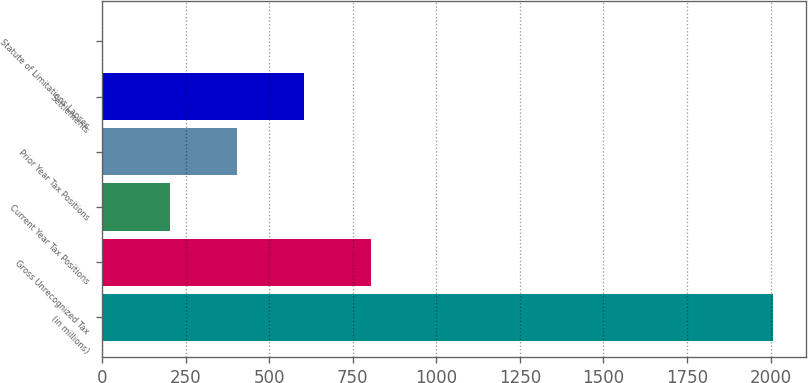Convert chart to OTSL. <chart><loc_0><loc_0><loc_500><loc_500><bar_chart><fcel>(in millions)<fcel>Gross Unrecognized Tax<fcel>Current Year Tax Positions<fcel>Prior Year Tax Positions<fcel>Settlements<fcel>Statute of Limitations Lapses<nl><fcel>2007<fcel>803.4<fcel>201.6<fcel>402.2<fcel>602.8<fcel>1<nl></chart> 